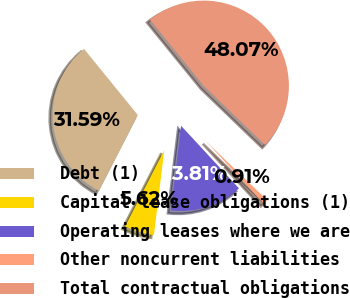Convert chart. <chart><loc_0><loc_0><loc_500><loc_500><pie_chart><fcel>Debt (1)<fcel>Capital lease obligations (1)<fcel>Operating leases where we are<fcel>Other noncurrent liabilities<fcel>Total contractual obligations<nl><fcel>31.59%<fcel>5.62%<fcel>13.81%<fcel>0.91%<fcel>48.07%<nl></chart> 